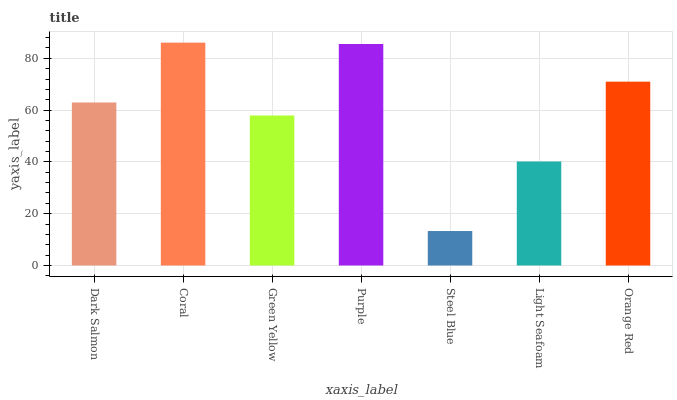Is Steel Blue the minimum?
Answer yes or no. Yes. Is Coral the maximum?
Answer yes or no. Yes. Is Green Yellow the minimum?
Answer yes or no. No. Is Green Yellow the maximum?
Answer yes or no. No. Is Coral greater than Green Yellow?
Answer yes or no. Yes. Is Green Yellow less than Coral?
Answer yes or no. Yes. Is Green Yellow greater than Coral?
Answer yes or no. No. Is Coral less than Green Yellow?
Answer yes or no. No. Is Dark Salmon the high median?
Answer yes or no. Yes. Is Dark Salmon the low median?
Answer yes or no. Yes. Is Purple the high median?
Answer yes or no. No. Is Steel Blue the low median?
Answer yes or no. No. 